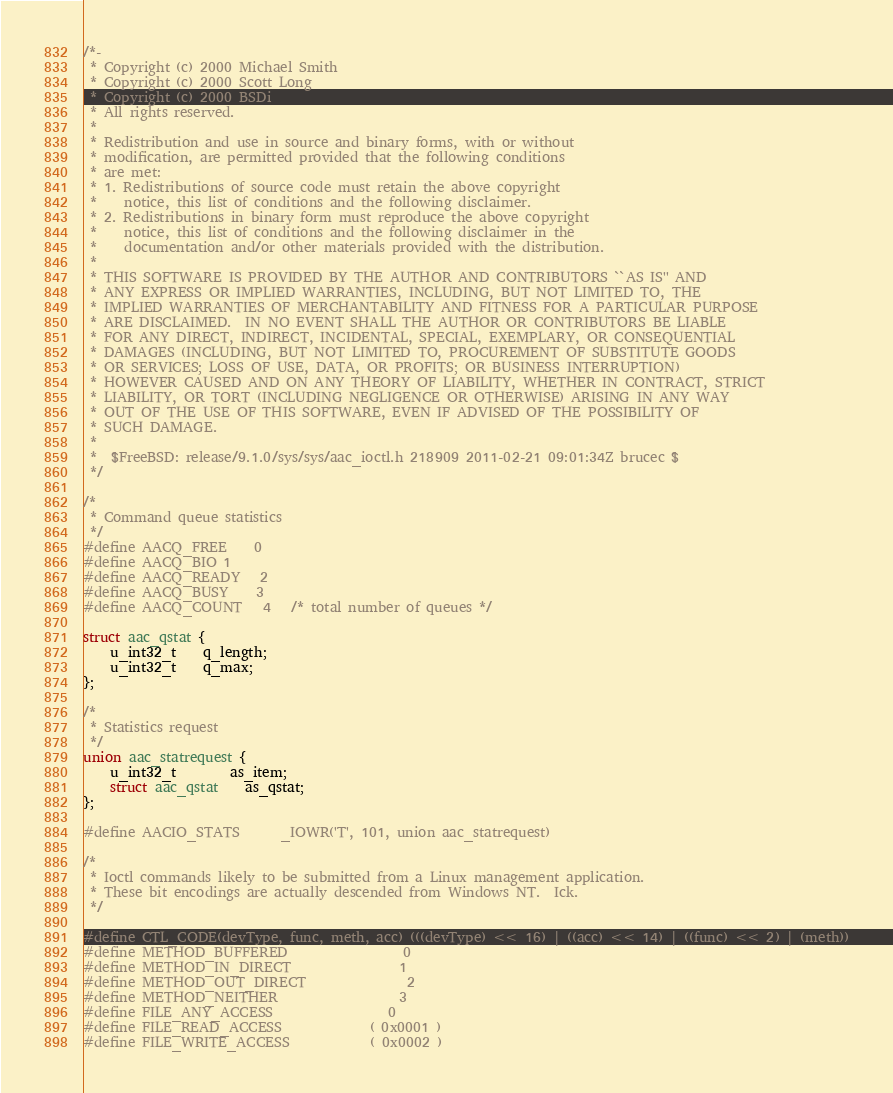<code> <loc_0><loc_0><loc_500><loc_500><_C_>/*-
 * Copyright (c) 2000 Michael Smith
 * Copyright (c) 2000 Scott Long
 * Copyright (c) 2000 BSDi
 * All rights reserved.
 *
 * Redistribution and use in source and binary forms, with or without
 * modification, are permitted provided that the following conditions
 * are met:
 * 1. Redistributions of source code must retain the above copyright
 *    notice, this list of conditions and the following disclaimer.
 * 2. Redistributions in binary form must reproduce the above copyright
 *    notice, this list of conditions and the following disclaimer in the
 *    documentation and/or other materials provided with the distribution.
 *
 * THIS SOFTWARE IS PROVIDED BY THE AUTHOR AND CONTRIBUTORS ``AS IS'' AND
 * ANY EXPRESS OR IMPLIED WARRANTIES, INCLUDING, BUT NOT LIMITED TO, THE
 * IMPLIED WARRANTIES OF MERCHANTABILITY AND FITNESS FOR A PARTICULAR PURPOSE
 * ARE DISCLAIMED.  IN NO EVENT SHALL THE AUTHOR OR CONTRIBUTORS BE LIABLE
 * FOR ANY DIRECT, INDIRECT, INCIDENTAL, SPECIAL, EXEMPLARY, OR CONSEQUENTIAL
 * DAMAGES (INCLUDING, BUT NOT LIMITED TO, PROCUREMENT OF SUBSTITUTE GOODS
 * OR SERVICES; LOSS OF USE, DATA, OR PROFITS; OR BUSINESS INTERRUPTION)
 * HOWEVER CAUSED AND ON ANY THEORY OF LIABILITY, WHETHER IN CONTRACT, STRICT
 * LIABILITY, OR TORT (INCLUDING NEGLIGENCE OR OTHERWISE) ARISING IN ANY WAY
 * OUT OF THE USE OF THIS SOFTWARE, EVEN IF ADVISED OF THE POSSIBILITY OF
 * SUCH DAMAGE.
 *
 *	$FreeBSD: release/9.1.0/sys/sys/aac_ioctl.h 218909 2011-02-21 09:01:34Z brucec $
 */

/*
 * Command queue statistics
 */
#define AACQ_FREE	0
#define AACQ_BIO	1
#define AACQ_READY	2
#define AACQ_BUSY	3
#define AACQ_COUNT	4	/* total number of queues */

struct aac_qstat {
	u_int32_t	q_length;
	u_int32_t	q_max;
};

/*
 * Statistics request
 */
union aac_statrequest {
	u_int32_t		as_item;
	struct aac_qstat	as_qstat;
};

#define AACIO_STATS		_IOWR('T', 101, union aac_statrequest)

/*
 * Ioctl commands likely to be submitted from a Linux management application.
 * These bit encodings are actually descended from Windows NT.  Ick.
 */

#define CTL_CODE(devType, func, meth, acc) (((devType) << 16) | ((acc) << 14) | ((func) << 2) | (meth))
#define METHOD_BUFFERED                 0
#define METHOD_IN_DIRECT                1
#define METHOD_OUT_DIRECT               2
#define METHOD_NEITHER                  3
#define FILE_ANY_ACCESS                 0
#define FILE_READ_ACCESS          	( 0x0001 )
#define FILE_WRITE_ACCESS         	( 0x0002 )</code> 